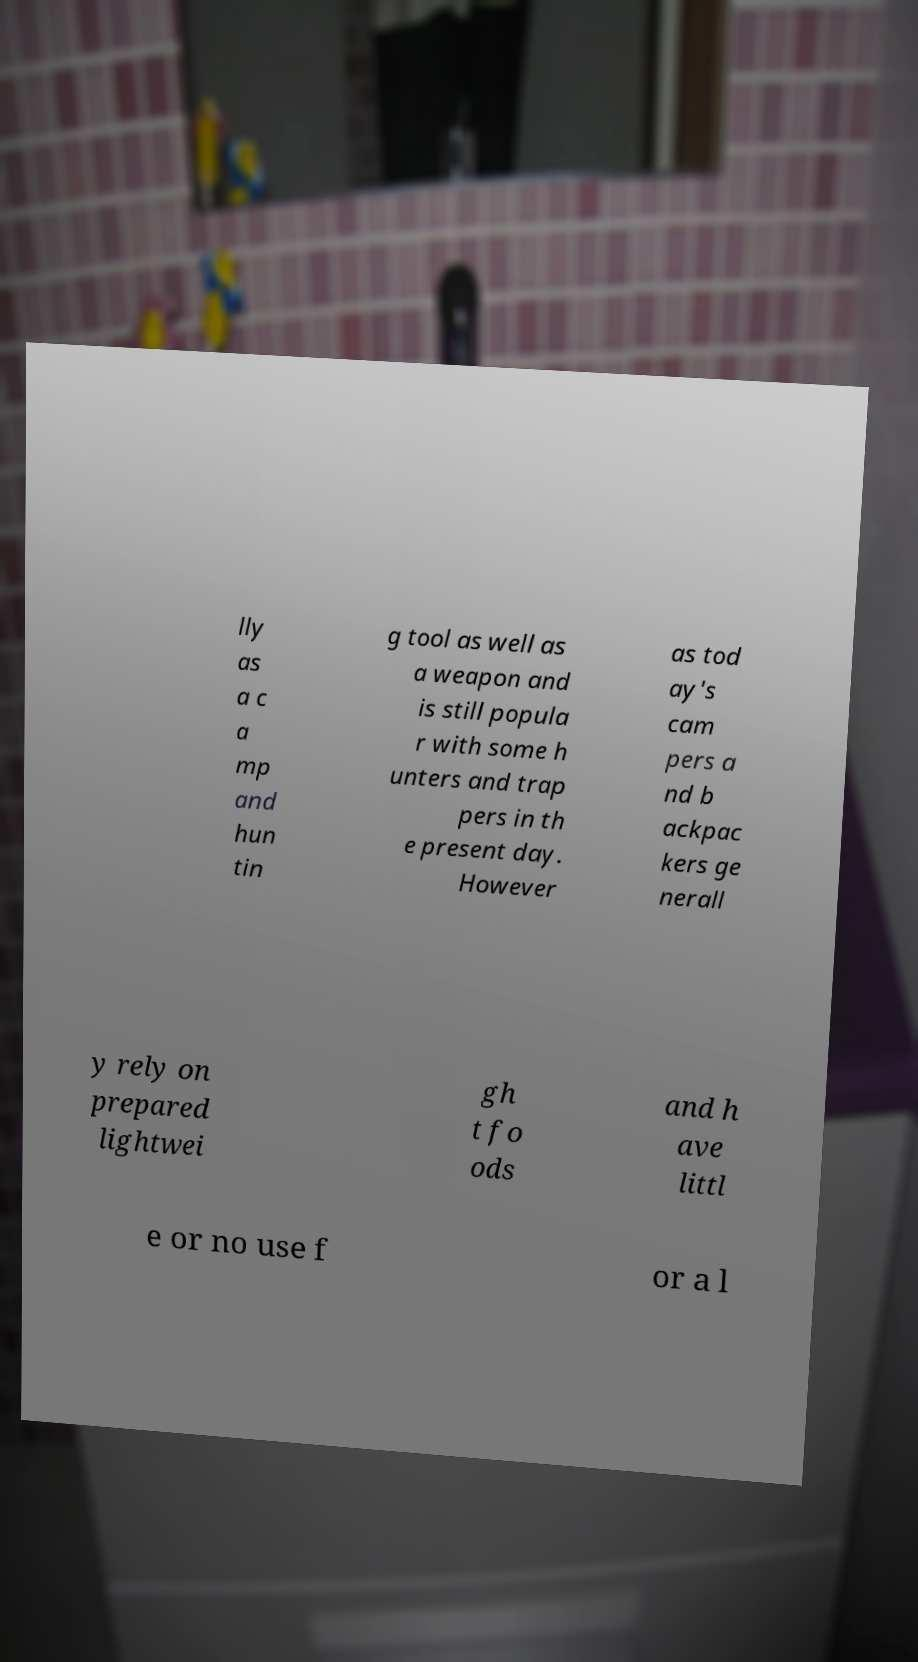Please read and relay the text visible in this image. What does it say? lly as a c a mp and hun tin g tool as well as a weapon and is still popula r with some h unters and trap pers in th e present day. However as tod ay's cam pers a nd b ackpac kers ge nerall y rely on prepared lightwei gh t fo ods and h ave littl e or no use f or a l 